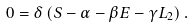<formula> <loc_0><loc_0><loc_500><loc_500>0 = \delta \left ( S - \alpha - \beta E - \gamma L _ { 2 } \right ) .</formula> 